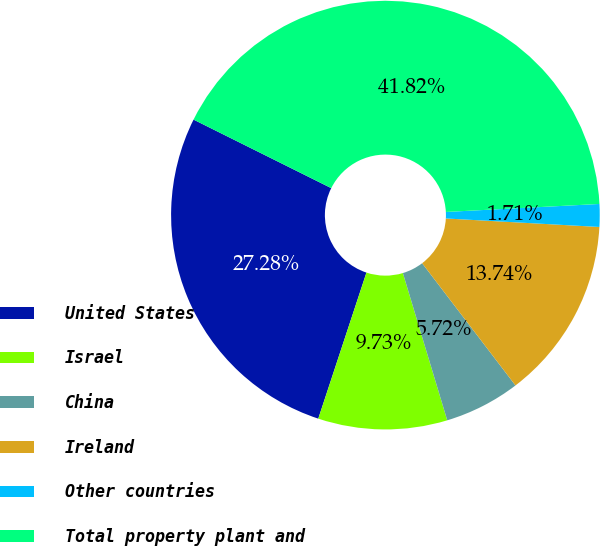Convert chart to OTSL. <chart><loc_0><loc_0><loc_500><loc_500><pie_chart><fcel>United States<fcel>Israel<fcel>China<fcel>Ireland<fcel>Other countries<fcel>Total property plant and<nl><fcel>27.28%<fcel>9.73%<fcel>5.72%<fcel>13.74%<fcel>1.71%<fcel>41.82%<nl></chart> 